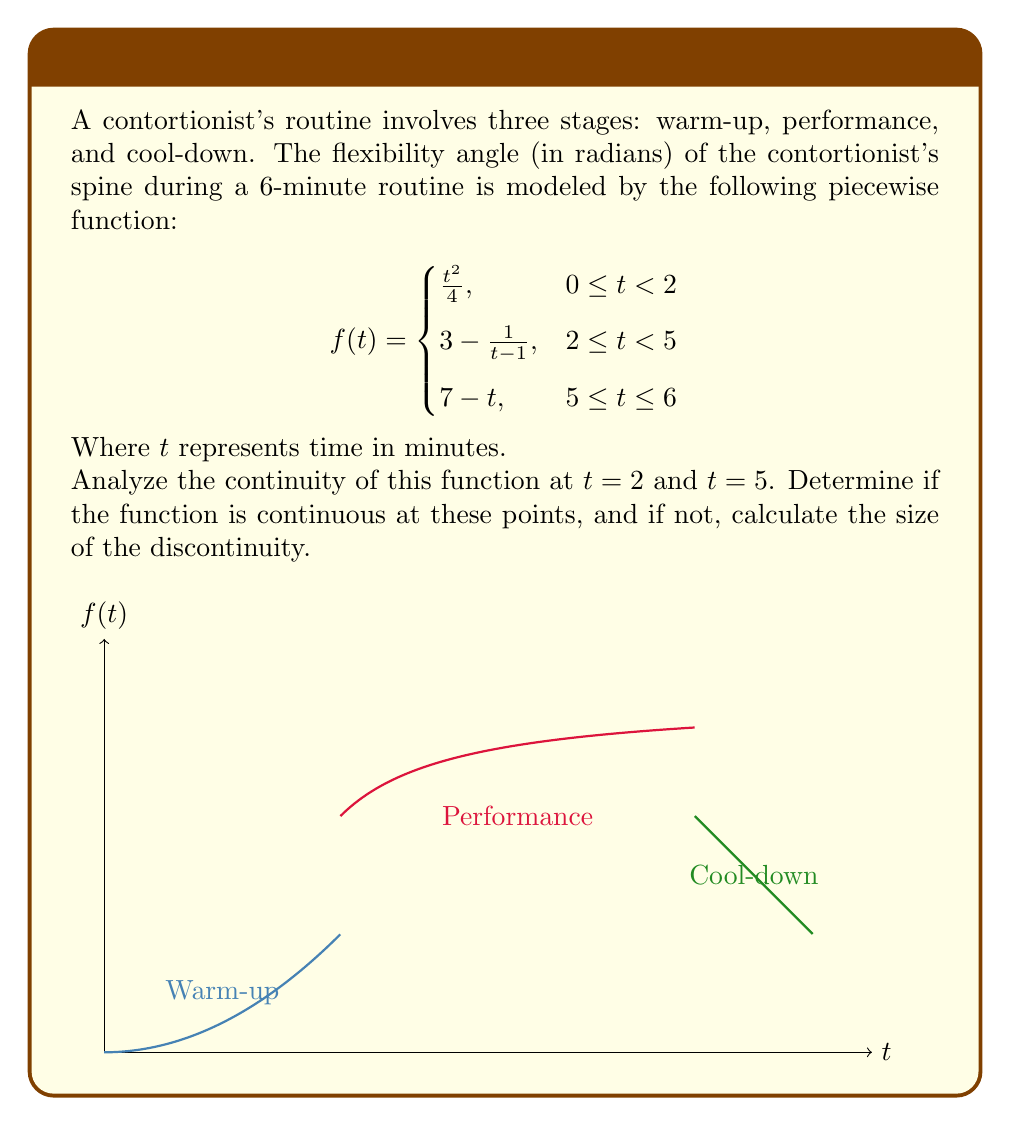Can you answer this question? To analyze the continuity at $t = 2$ and $t = 5$, we need to check three conditions for each point:
1. The function is defined at the point.
2. The limit of the function as we approach the point from both sides exists.
3. The limit equals the function value at that point.

For $t = 2$:

1. The function is defined at $t = 2$:
   $f(2) = 3 - \frac{1}{2-1} = 3 - 1 = 2$

2. Left-hand limit:
   $\lim_{t \to 2^-} f(t) = \lim_{t \to 2^-} \frac{t^2}{4} = \frac{2^2}{4} = 1$

   Right-hand limit:
   $\lim_{t \to 2^+} f(t) = \lim_{t \to 2^+} (3 - \frac{1}{t-1}) = 3 - \frac{1}{1} = 2$

3. The left-hand limit (1) does not equal the right-hand limit (2), so the function is not continuous at $t = 2$.

The size of the discontinuity at $t = 2$ is:
$|\lim_{t \to 2^+} f(t) - \lim_{t \to 2^-} f(t)| = |2 - 1| = 1$

For $t = 5$:

1. The function is defined at $t = 5$:
   $f(5) = 7 - 5 = 2$

2. Left-hand limit:
   $\lim_{t \to 5^-} f(t) = \lim_{t \to 5^-} (3 - \frac{1}{t-1}) = 3 - \frac{1}{4} = \frac{11}{4}$

   Right-hand limit:
   $\lim_{t \to 5^+} f(t) = \lim_{t \to 5^+} (7 - t) = 7 - 5 = 2$

3. The left-hand limit ($\frac{11}{4}$) does not equal the right-hand limit (2), so the function is not continuous at $t = 5$.

The size of the discontinuity at $t = 5$ is:
$|\lim_{t \to 5^+} f(t) - \lim_{t \to 5^-} f(t)| = |2 - \frac{11}{4}| = |\frac{8}{4} - \frac{11}{4}| = \frac{3}{4}$
Answer: The function is discontinuous at both $t = 2$ and $t = 5$. The size of the discontinuity is 1 at $t = 2$ and $\frac{3}{4}$ at $t = 5$. 